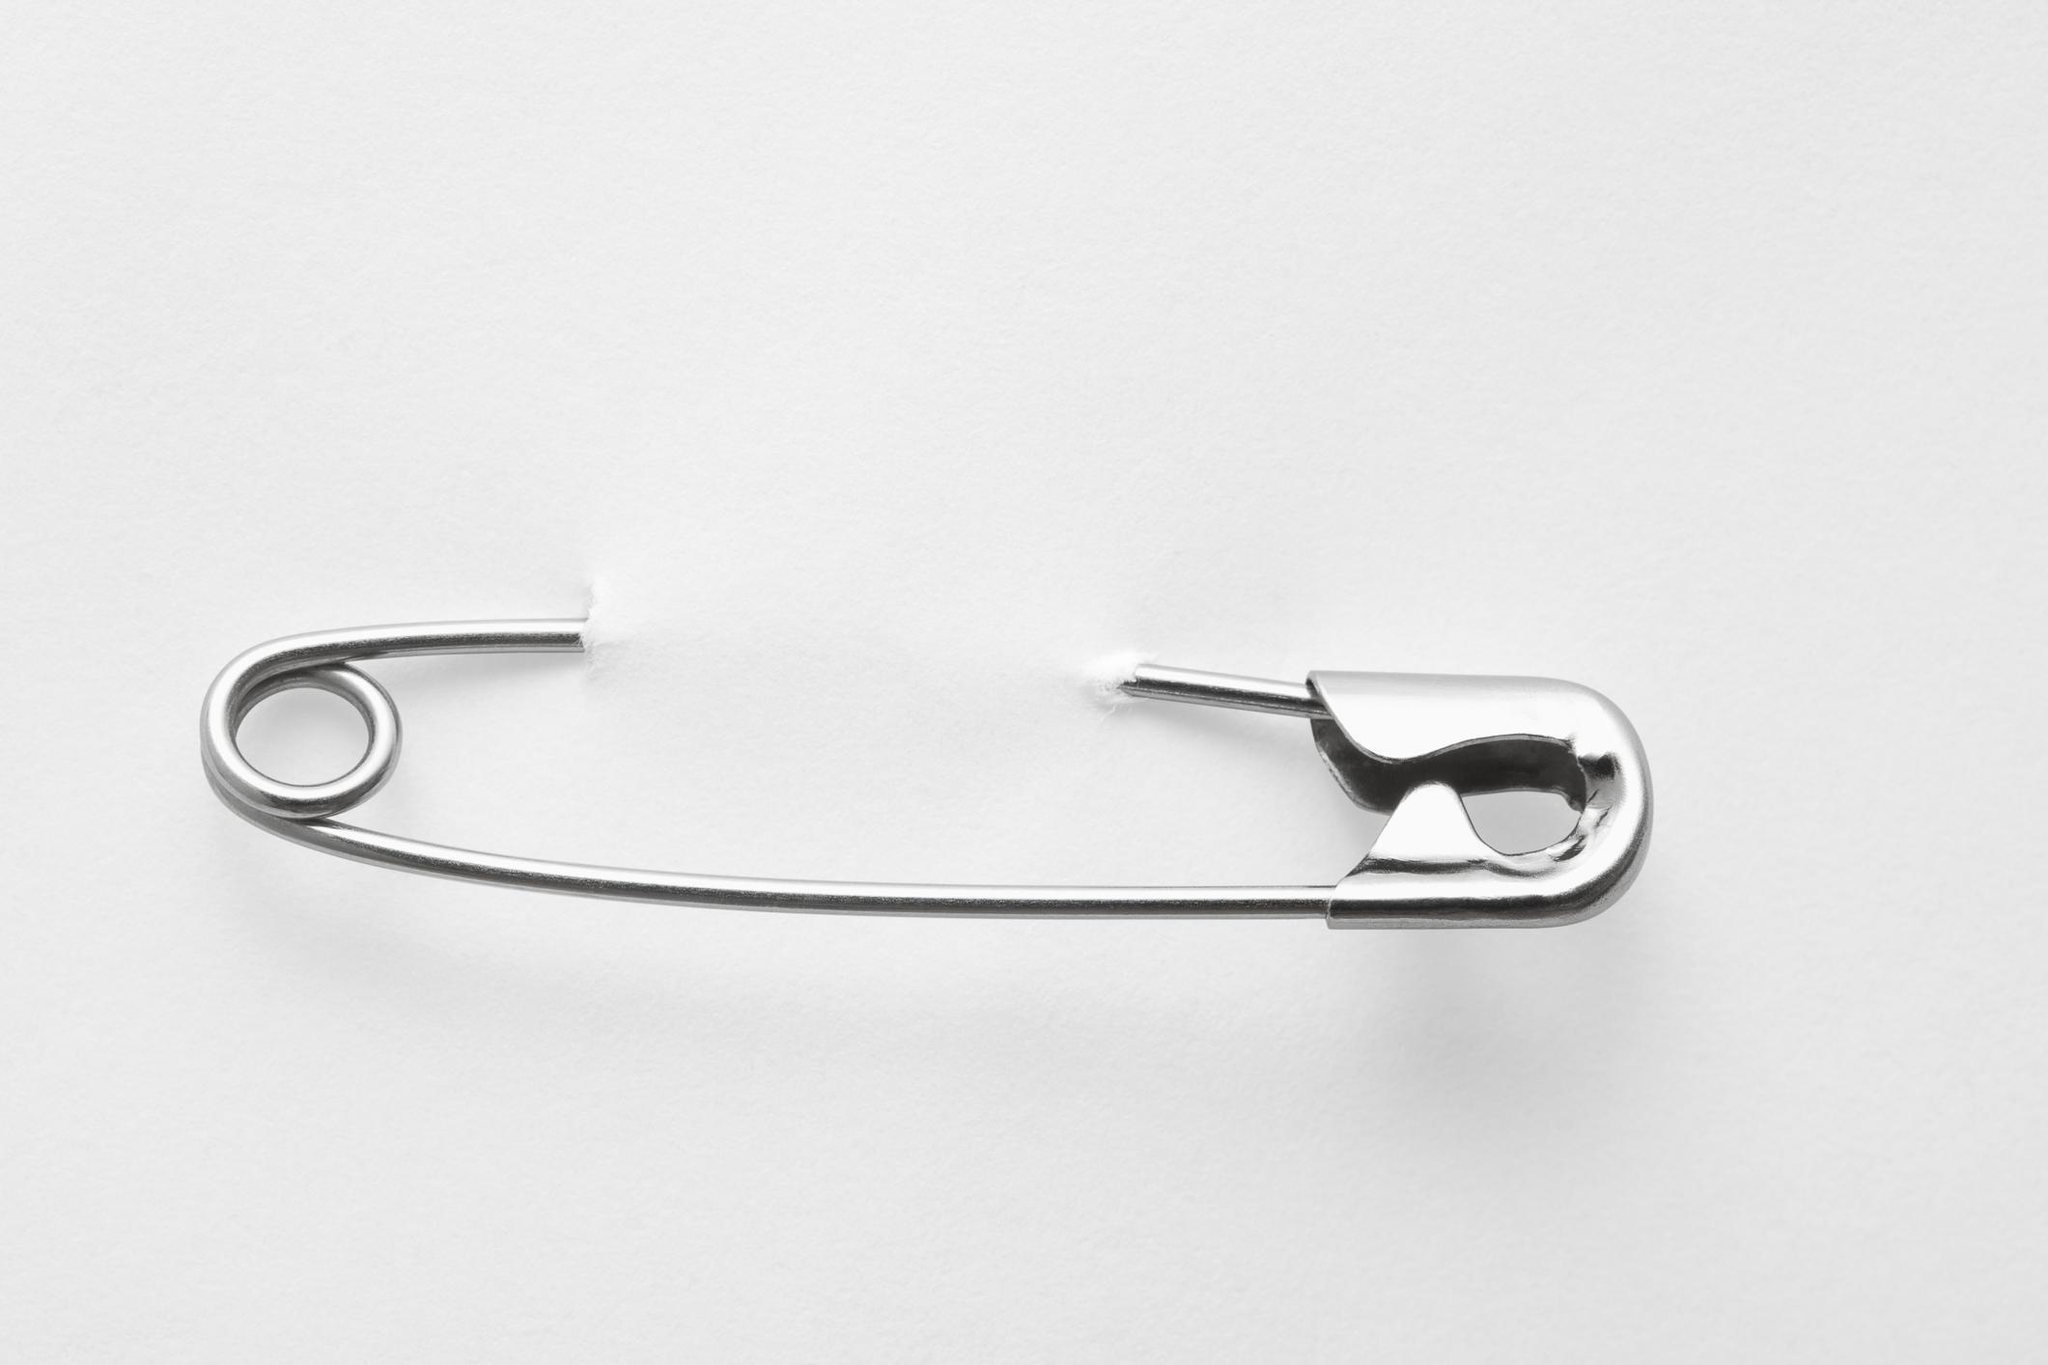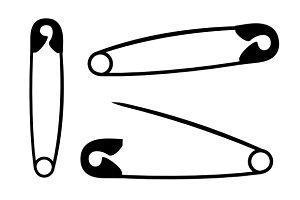The first image is the image on the left, the second image is the image on the right. Analyze the images presented: Is the assertion "The left image contains no more than one gold safety pin." valid? Answer yes or no. No. The first image is the image on the left, the second image is the image on the right. For the images shown, is this caption "One pin in the image on the right is open." true? Answer yes or no. Yes. 